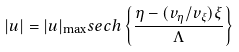<formula> <loc_0><loc_0><loc_500><loc_500>| u | = | u | _ { \max } s e c h \left \{ \frac { \eta - ( v _ { \eta } / v _ { \xi } ) \xi } { \Lambda } \right \}</formula> 